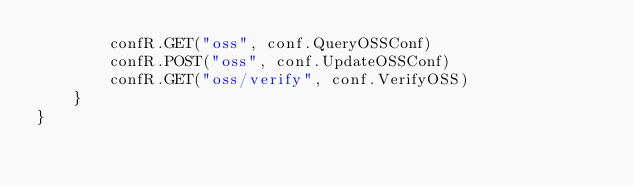Convert code to text. <code><loc_0><loc_0><loc_500><loc_500><_Go_>		confR.GET("oss", conf.QueryOSSConf)
		confR.POST("oss", conf.UpdateOSSConf)
		confR.GET("oss/verify", conf.VerifyOSS)
	}
}
</code> 